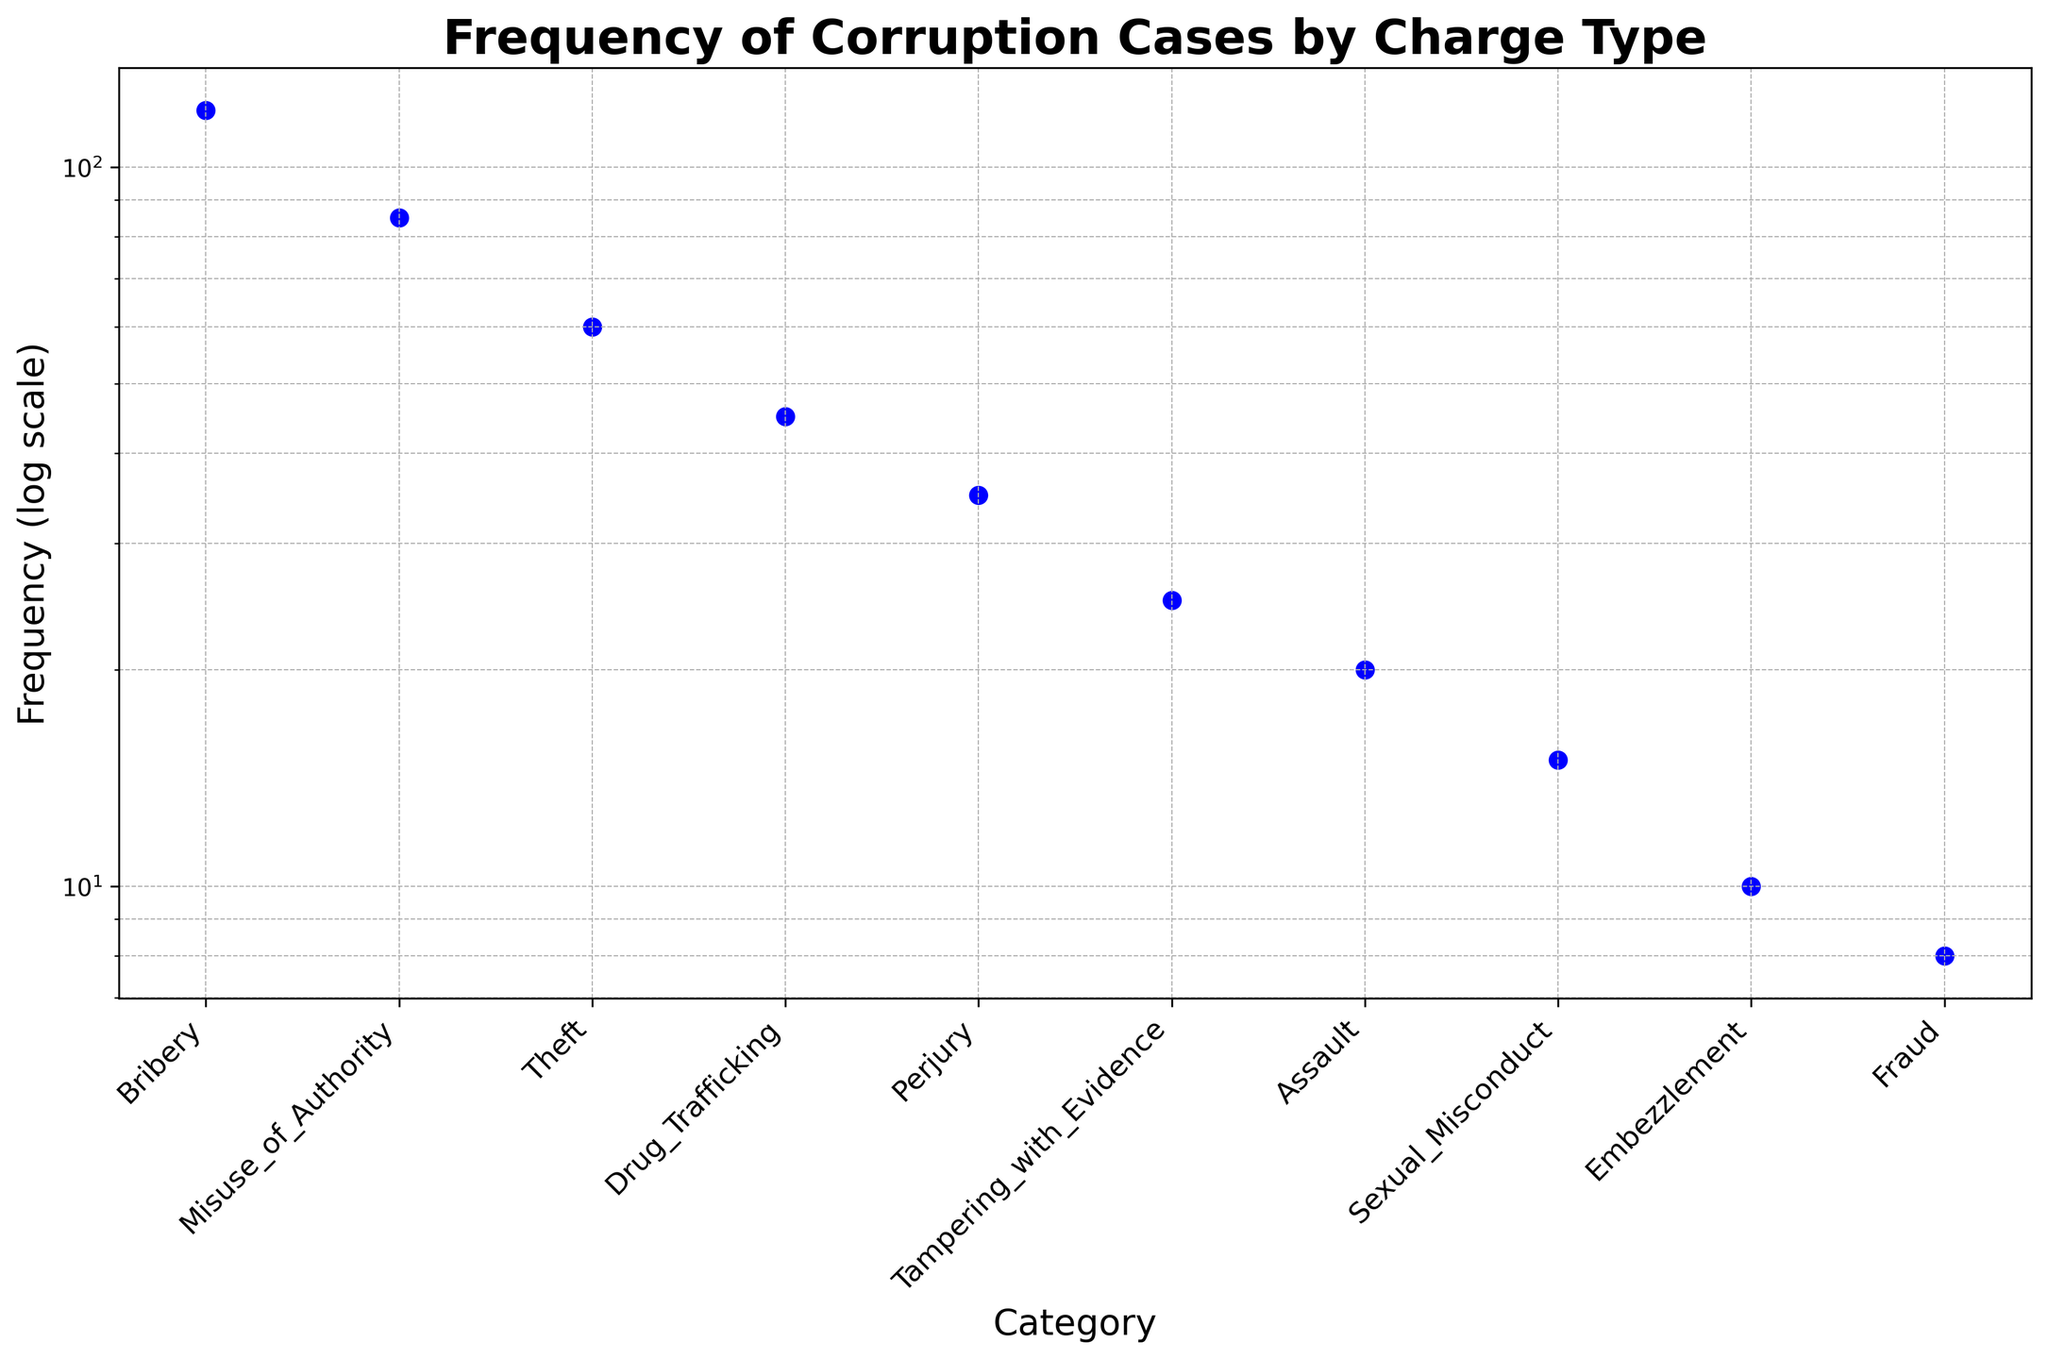Which category has the highest frequency of corruption cases? By observing the scatter plot, the point corresponding to the 'Bribery' category is at the highest position among all other points on the y-axis (log scale). Therefore, 'Bribery' has the highest frequency.
Answer: Bribery What is the combined frequency of 'Theft' and 'Drug Trafficking' cases? From the scatter plot, the frequencies for 'Theft' and 'Drug Trafficking' are 60 and 45 respectively. Adding these together, we get 60 + 45 = 105.
Answer: 105 Which has more cases, 'Assault' or 'Sexual Misconduct'? The scatter plot shows the frequency of 'Assault' is 20 and 'Sexual Misconduct' is 15. Therefore, 'Assault' has more cases.
Answer: Assault How many categories have a frequency between 20 and 100 on the log scale? The relevant categories based on the scatter plot are: 'Misuse_of_Authority' (85), 'Theft' (60), 'Drug Trafficking' (45), 'Perjury' (35), and 'Tampering_with_Evidence' (25). Counting these categories gives us a total of 5.
Answer: 5 What is the difference in frequency between 'Bribery' and 'Fraud'? The frequencies from the plot are 120 for 'Bribery' and 8 for 'Fraud'. The difference is 120 - 8 = 112.
Answer: 112 Is 'Perjury' more frequent than 'Theft'? According to the scatter plot, the frequency of 'Perjury' is 35 and 'Theft' is 60, meaning 'Theft' is more frequent than 'Perjury'.
Answer: No Summing up all the categories with frequencies below 30, what do you get? From the scatter plot, the relevant categories and their frequencies are: 'Tampering_with_Evidence' (25), 'Assault' (20), 'Sexual_Misconduct' (15), 'Embezzlement' (10), 'Fraud' (8). Summing these, we get 25 + 20 + 15 + 10 + 8 = 78.
Answer: 78 What is the average frequency of the cases for 'Embezzlement', 'Fraud', and 'Assault'? The frequencies from the plot are: 'Embezzlement' (10), 'Fraud' (8), and 'Assault' (20). Adding these gives 10 + 8 + 20 = 38. The average is 38 / 3 ≈ 12.67.
Answer: 12.67 Among 'Theft', 'Drug Trafficking', and 'Perjury', which category has the maximum frequency? Checking the scatter plot, the frequencies are: 'Theft' (60), 'Drug Trafficking' (45), and 'Perjury' (35). Therefore, 'Theft' has the maximum frequency among them.
Answer: Theft 